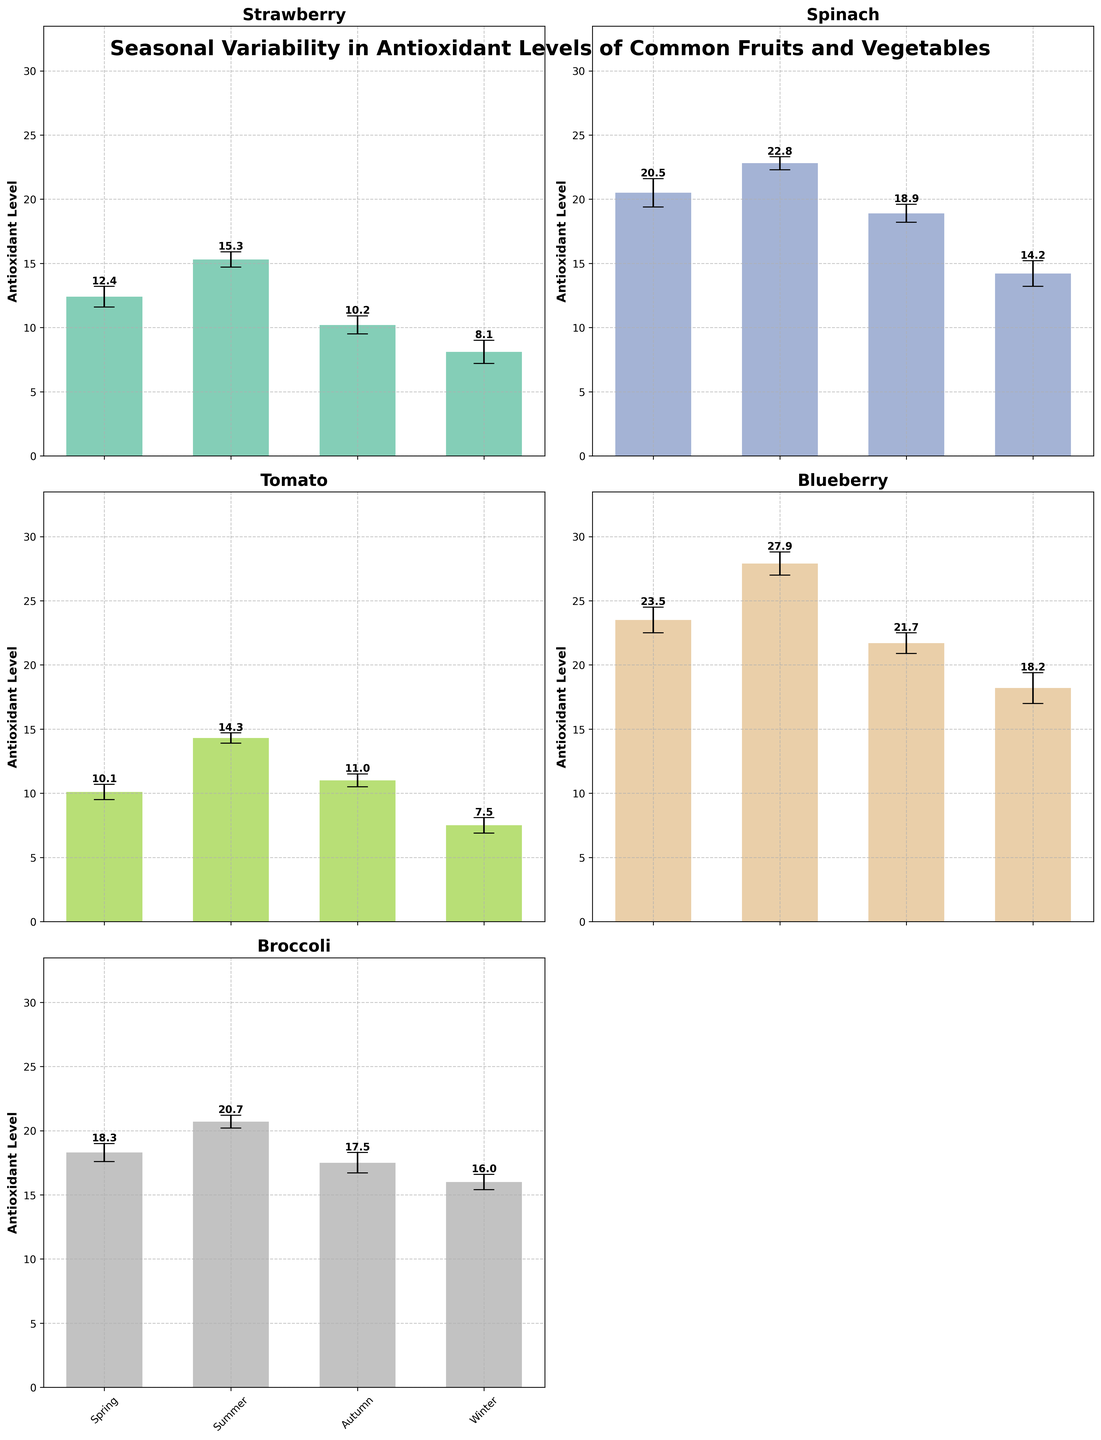What is the title of the figure? Look at the top of the figure to find the title. The title is placed prominently and is usually larger in font size and bold.
Answer: Seasonal Variability in Antioxidant Levels of Common Fruits and Vegetables Which fruit or vegetable has the highest average antioxidant level in summer? Examine each subplot and look at the bars for the 'Summer' season. The one with the highest bar indicates the highest average antioxidant level.
Answer: Blueberry What is the average antioxidant level of Spinach in autumn? Find the Spinach subplot and look at the bar corresponding to 'Autumn'. Note the height or value of the bar.
Answer: 18.9 Which season has the lowest average antioxidant level for Strawberries? In the Strawberry subplot, compare the heights of the bars across all seasons and find the one with the lowest height.
Answer: Winter How much higher is the antioxidant level of Blueberry in summer compared to winter? Locate Blueberry in the 'Summer' and 'Winter' bars and subtract the 'Winter' value from the 'Summer' value. The 'Summer' value is 27.9, and the 'Winter' value is 18.2. Thus, 27.9 - 18.2 = 9.7
Answer: 9.7 What is the error margin for Tomato in spring? In the Tomato subplot, identify the error bar associated with the 'Spring' season. The length of the error bar represents the error margin.
Answer: 0.6 How does the antioxidant level of Broccoli in autumn compare to that in winter? Find the Broccoli subplot and compare the heights of the bars between 'Autumn' and 'Winter'. The value for 'Autumn' is 17.5 and for 'Winter' is 16.0. Since 17.5 > 16.0, 'Autumn' is higher.
Answer: Autumn is higher Which fruit or vegetable shows the smallest difference in average antioxidant levels between the seasons? For each subplot, calculate the difference between the highest and lowest bars (maximum minus minimum). Compare these differences across all subplots to find the smallest. For Strawberry, the range is 15.3 - 8.1 = 7.2. For Spinach, the range is 22.8 - 14.2 = 8.6. For Tomato, the range is 14.3 - 7.5 = 6.8. For Blueberry, the range is 27.9 - 18.2 = 9.7. For Broccoli, the range is 20.7 - 16.0 = 4.7. The smallest difference is for Broccoli.
Answer: Broccoli Compare the antioxidant levels of Spinach and Broccoli in summer. Which one is higher? Look at the Spinach and Broccoli subplots, focusing on the 'Summer' season. Compare their bar heights. Spinach has a value of 22.8, while Broccoli has a value of 20.7. So, Spinach is higher.
Answer: Spinach 